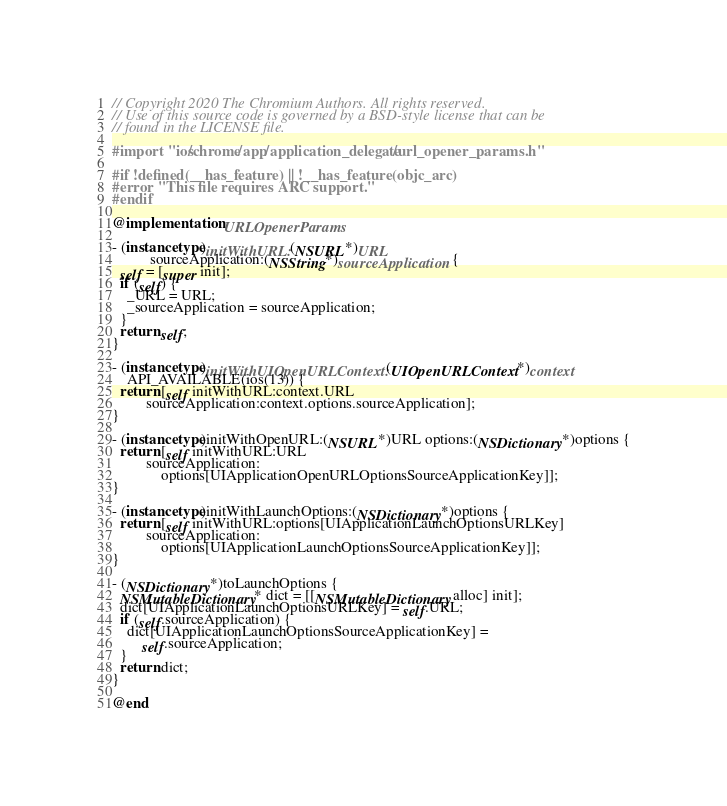<code> <loc_0><loc_0><loc_500><loc_500><_ObjectiveC_>// Copyright 2020 The Chromium Authors. All rights reserved.
// Use of this source code is governed by a BSD-style license that can be
// found in the LICENSE file.

#import "ios/chrome/app/application_delegate/url_opener_params.h"

#if !defined(__has_feature) || !__has_feature(objc_arc)
#error "This file requires ARC support."
#endif

@implementation URLOpenerParams

- (instancetype)initWithURL:(NSURL*)URL
          sourceApplication:(NSString*)sourceApplication {
  self = [super init];
  if (self) {
    _URL = URL;
    _sourceApplication = sourceApplication;
  }
  return self;
}

- (instancetype)initWithUIOpenURLContext:(UIOpenURLContext*)context
    API_AVAILABLE(ios(13)) {
  return [self initWithURL:context.URL
         sourceApplication:context.options.sourceApplication];
}

- (instancetype)initWithOpenURL:(NSURL*)URL options:(NSDictionary*)options {
  return [self initWithURL:URL
         sourceApplication:
             options[UIApplicationOpenURLOptionsSourceApplicationKey]];
}

- (instancetype)initWithLaunchOptions:(NSDictionary*)options {
  return [self initWithURL:options[UIApplicationLaunchOptionsURLKey]
         sourceApplication:
             options[UIApplicationLaunchOptionsSourceApplicationKey]];
}

- (NSDictionary*)toLaunchOptions {
  NSMutableDictionary* dict = [[NSMutableDictionary alloc] init];
  dict[UIApplicationLaunchOptionsURLKey] = self.URL;
  if (self.sourceApplication) {
    dict[UIApplicationLaunchOptionsSourceApplicationKey] =
        self.sourceApplication;
  }
  return dict;
}

@end
</code> 